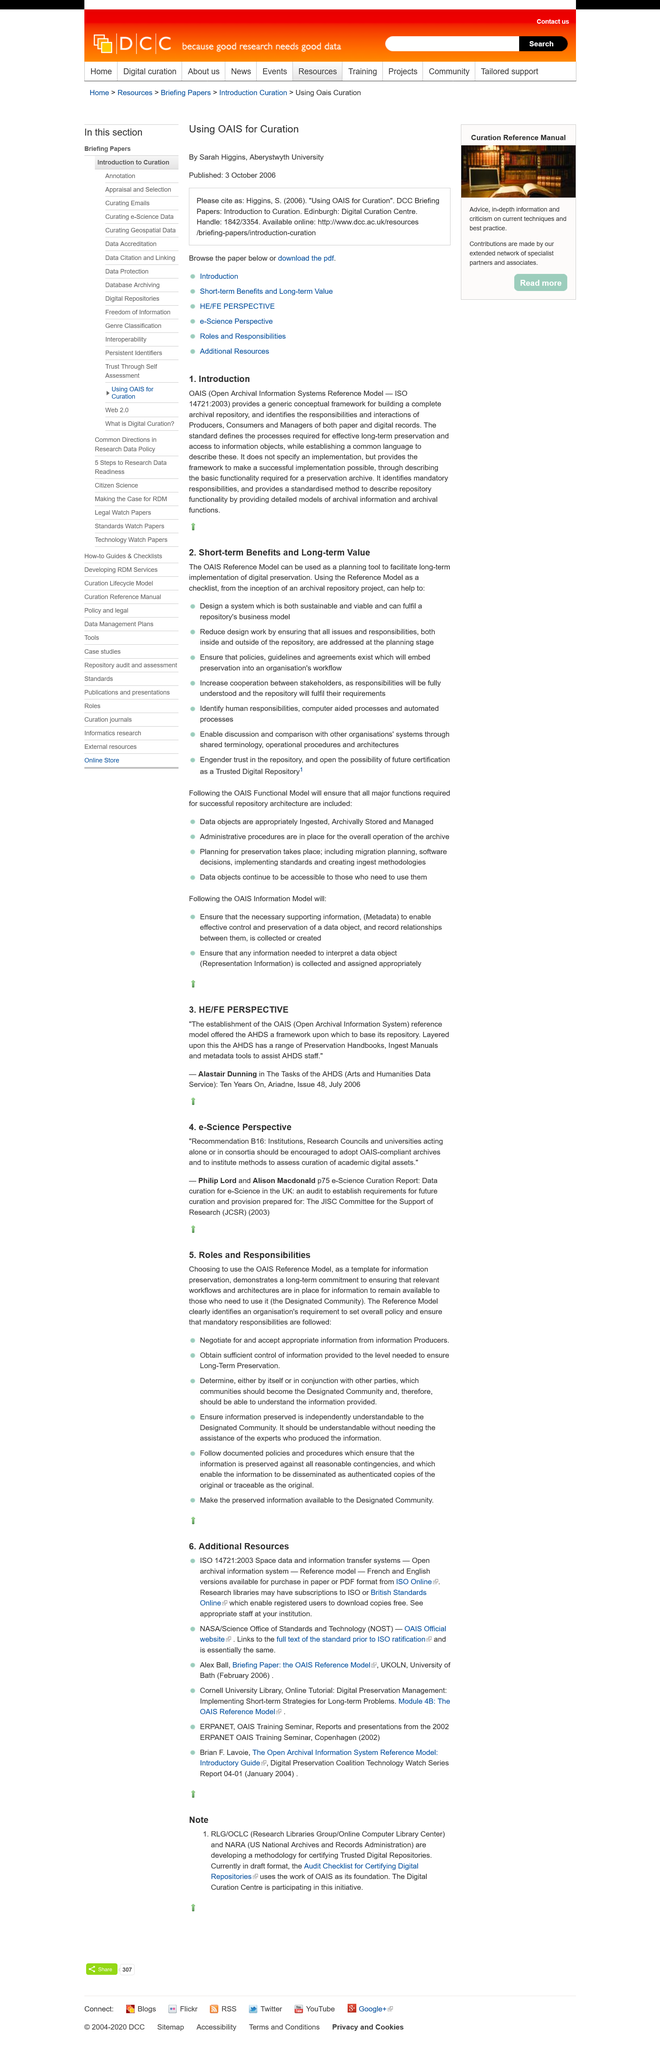Identify some key points in this picture. The title of this page is "e-Science Perspective". Choosing to use the OAIS Reference Model demonstrates a long-term commitment to ensuring that relevant workflows and architectures are in place for information to remain available to the Designated Community. It is confirmed that mandatory responsibilities have been properly identified. The e-Science Curation Report was authored by Philip Lord and Alison Macdonald. The Reference Model identifies the need for an organization to establish overall policy and ensure that mandatory responsibilities are fulfilled. 